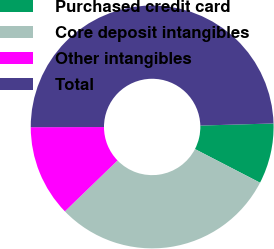Convert chart. <chart><loc_0><loc_0><loc_500><loc_500><pie_chart><fcel>Purchased credit card<fcel>Core deposit intangibles<fcel>Other intangibles<fcel>Total<nl><fcel>8.05%<fcel>30.17%<fcel>12.2%<fcel>49.57%<nl></chart> 